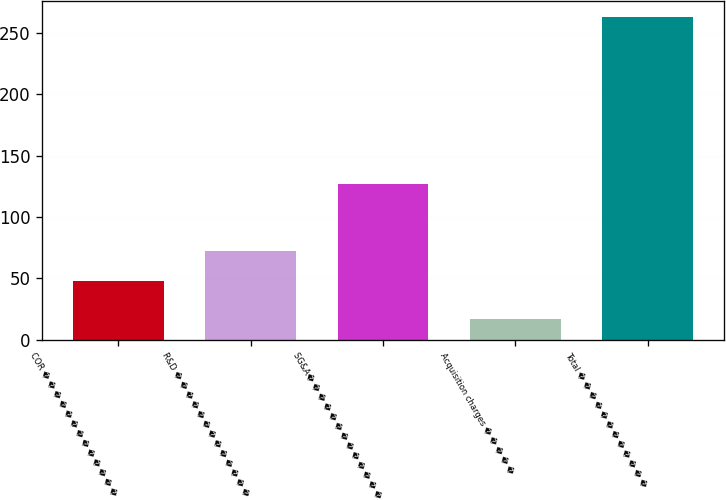Convert chart. <chart><loc_0><loc_0><loc_500><loc_500><bar_chart><fcel>COR � � � � � � � � � � � � �<fcel>R&D � � � � � � � � � � � � �<fcel>SG&A� � � � � � � � � � � � �<fcel>Acquisition charges � � � � �<fcel>Total � � � � � � � � � � � �<nl><fcel>48<fcel>72.6<fcel>127<fcel>17<fcel>263<nl></chart> 